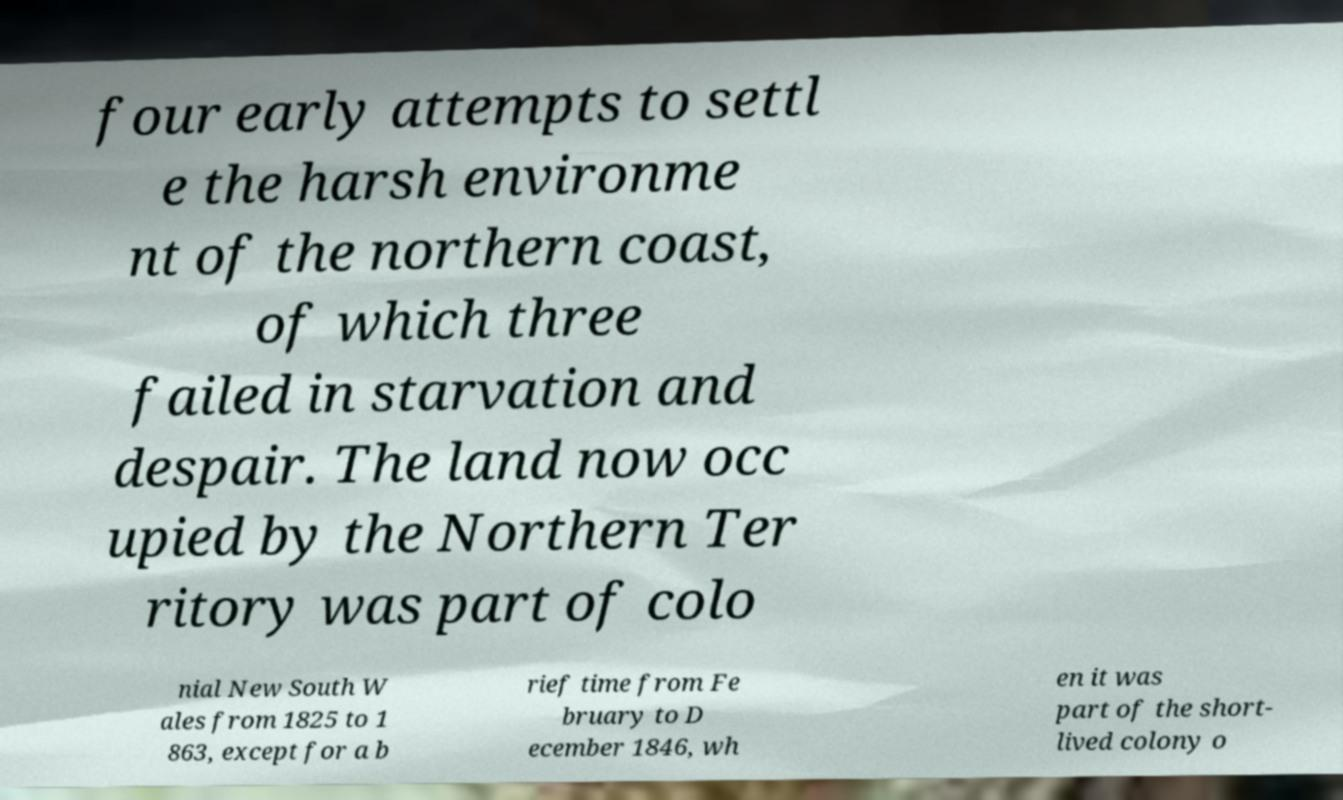I need the written content from this picture converted into text. Can you do that? four early attempts to settl e the harsh environme nt of the northern coast, of which three failed in starvation and despair. The land now occ upied by the Northern Ter ritory was part of colo nial New South W ales from 1825 to 1 863, except for a b rief time from Fe bruary to D ecember 1846, wh en it was part of the short- lived colony o 